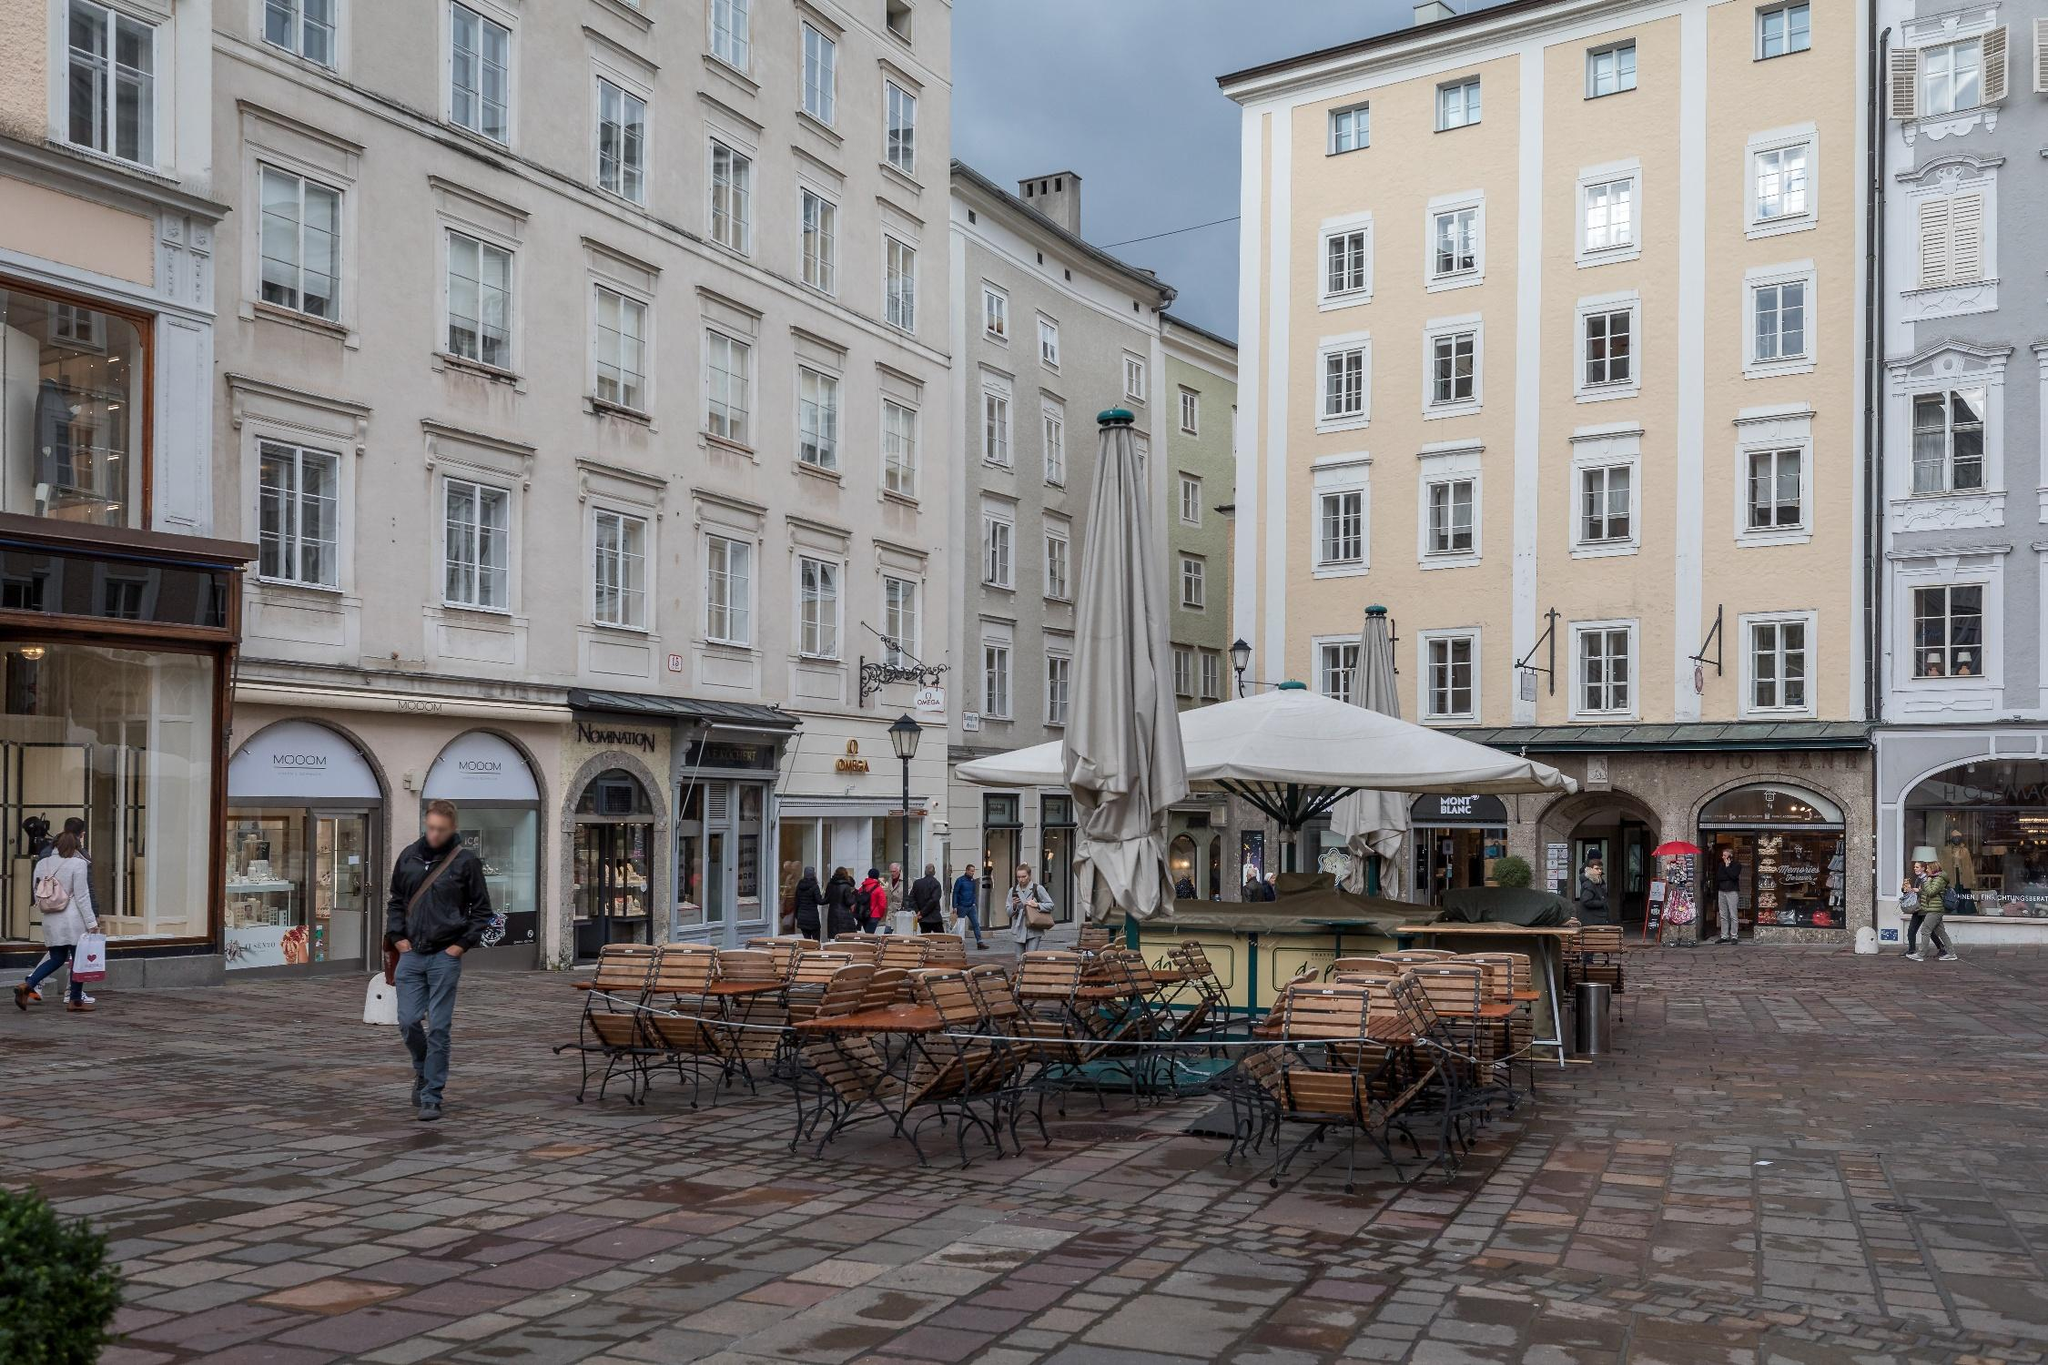Imagine a fantastic scenario happening in this street corner. Picture this: On a tranquil evening, as the sun begins to set, the street corner suddenly transforms. The outdoor seating area morphs into a magical forest glade, with the wooden benches turning into moss-covered stones and the white umbrellas becoming oversized, glowing mushrooms. The cobblestones shimmer like enchanted gems, casting colorful reflections. Ethereal creatures, like fairies and sprites, emerge from the shop windows, bringing the scene to life with their luminescent glow. The shops are now portals to other realms, offering glimpses of mystical landscapes and hidden treasures. This surreal transformation captivates the few passersby who find themselves in the midst of a fairy-tale wonderland, leaving them mesmerized by the enchanting beauty and magic of the moment. 